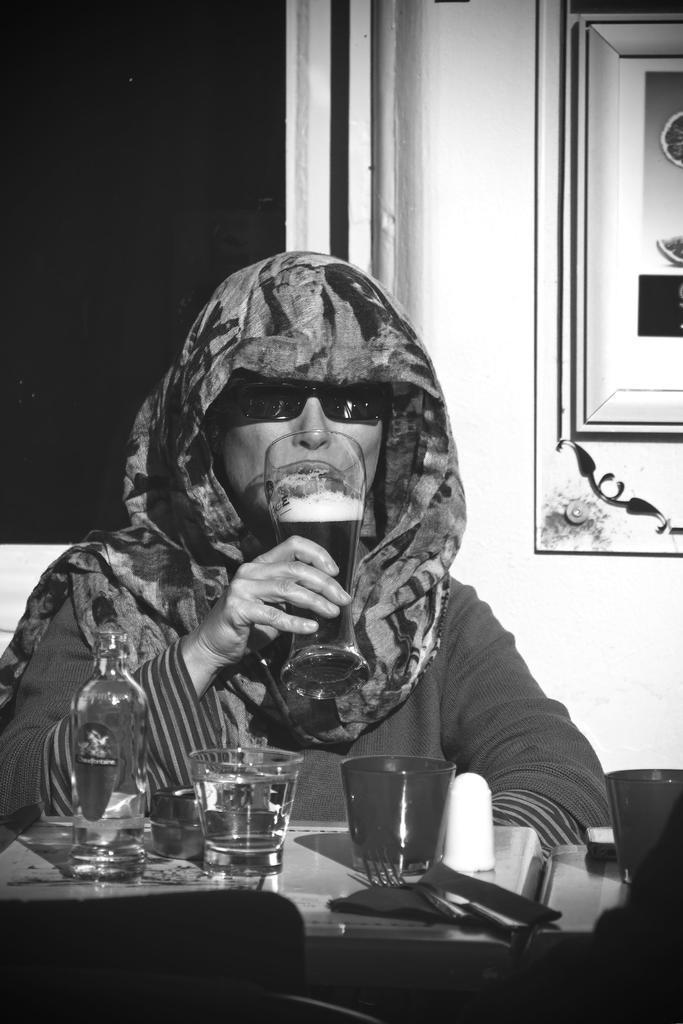Could you give a brief overview of what you see in this image? This is a black and white picture. Here we can see a person who is drinking with the glass. This is table. On the table there is a bottle, and glasses. On the background there is a wall and this is frame. 